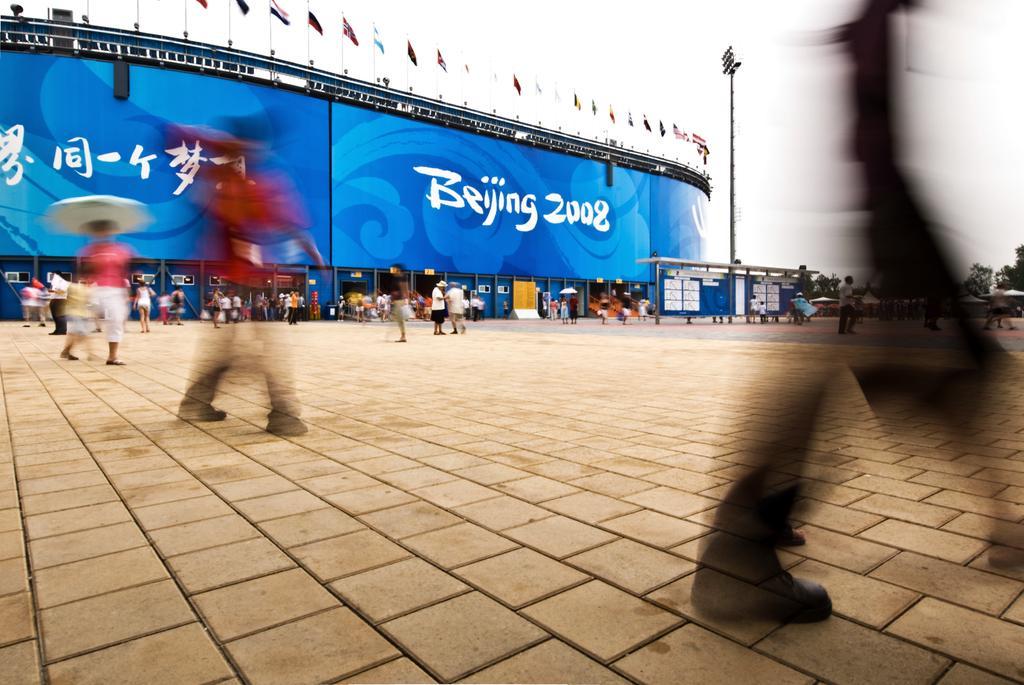Could you give a brief overview of what you see in this image? In this image in the background there is a banner with some text written on it which is blue in colour. In front of the banner there are persons and there is a pole. On the banner there are flags, which are on the top of the banners and the sky is cloudy. 